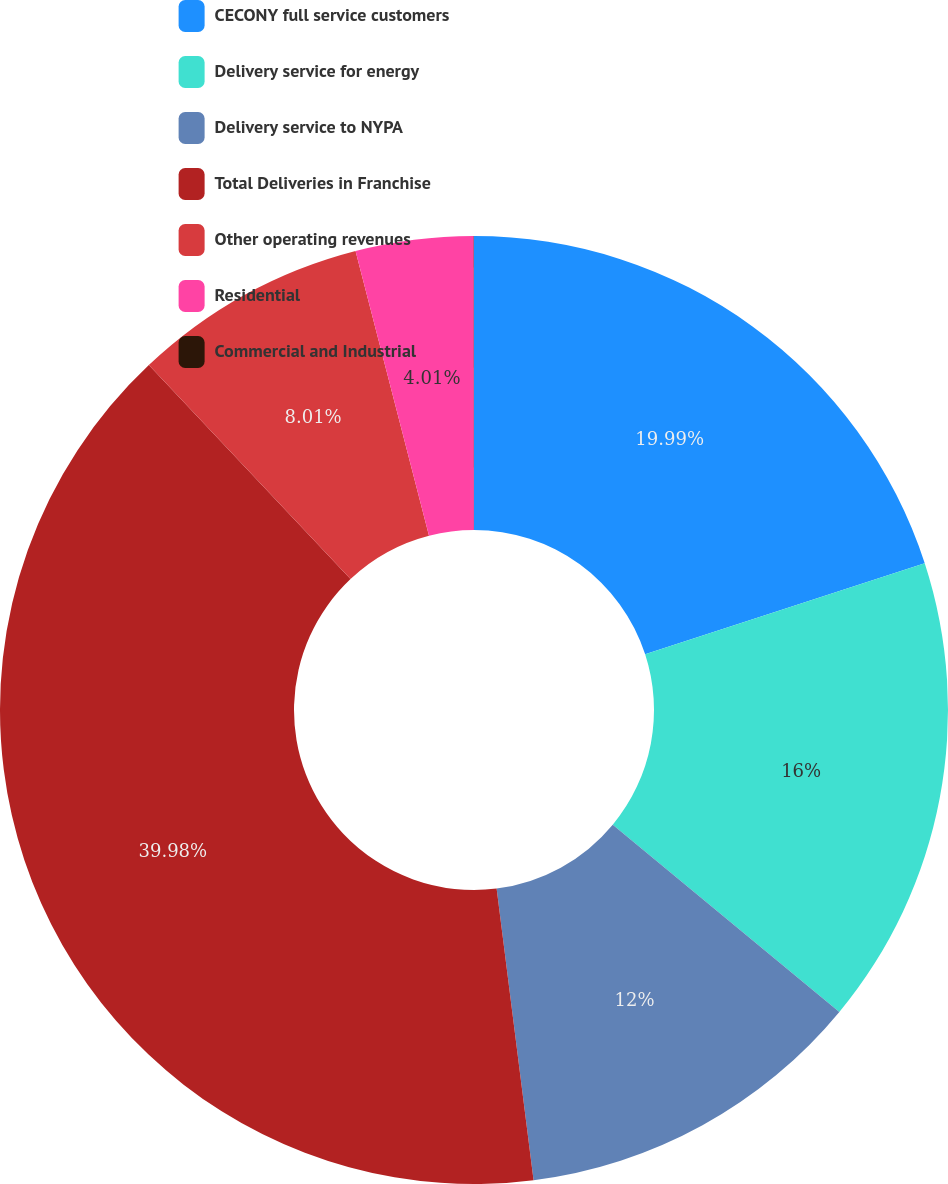<chart> <loc_0><loc_0><loc_500><loc_500><pie_chart><fcel>CECONY full service customers<fcel>Delivery service for energy<fcel>Delivery service to NYPA<fcel>Total Deliveries in Franchise<fcel>Other operating revenues<fcel>Residential<fcel>Commercial and Industrial<nl><fcel>19.99%<fcel>16.0%<fcel>12.0%<fcel>39.97%<fcel>8.01%<fcel>4.01%<fcel>0.01%<nl></chart> 